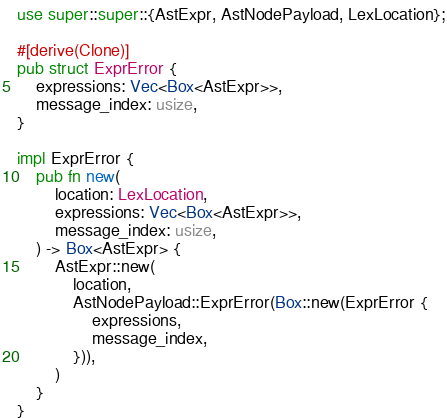Convert code to text. <code><loc_0><loc_0><loc_500><loc_500><_Rust_>use super::super::{AstExpr, AstNodePayload, LexLocation};

#[derive(Clone)]
pub struct ExprError {
    expressions: Vec<Box<AstExpr>>,
    message_index: usize,
}

impl ExprError {
    pub fn new(
        location: LexLocation,
        expressions: Vec<Box<AstExpr>>,
        message_index: usize,
    ) -> Box<AstExpr> {
        AstExpr::new(
            location,
            AstNodePayload::ExprError(Box::new(ExprError {
                expressions,
                message_index,
            })),
        )
    }
}
</code> 